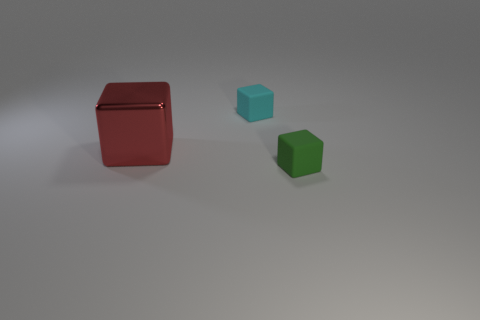Subtract all tiny matte blocks. How many blocks are left? 1 Add 3 tiny green objects. How many objects exist? 6 Subtract all small cyan cubes. Subtract all metal things. How many objects are left? 1 Add 3 tiny blocks. How many tiny blocks are left? 5 Add 2 things. How many things exist? 5 Subtract 0 brown balls. How many objects are left? 3 